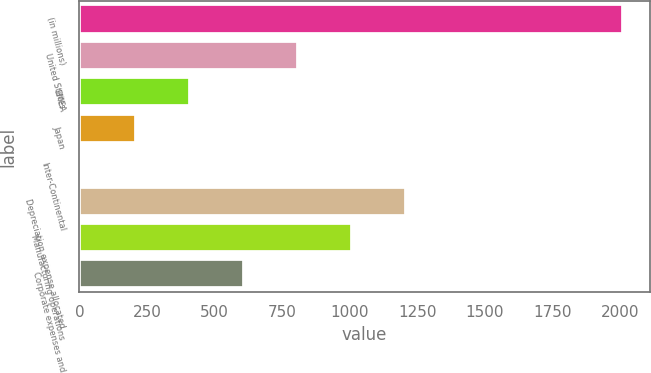Convert chart to OTSL. <chart><loc_0><loc_0><loc_500><loc_500><bar_chart><fcel>(in millions)<fcel>United States<fcel>EMEA<fcel>Japan<fcel>Inter-Continental<fcel>Depreciation expense allocated<fcel>Manufacturing operations<fcel>Corporate expenses and<nl><fcel>2010<fcel>808.8<fcel>408.4<fcel>208.2<fcel>8<fcel>1209.2<fcel>1009<fcel>608.6<nl></chart> 